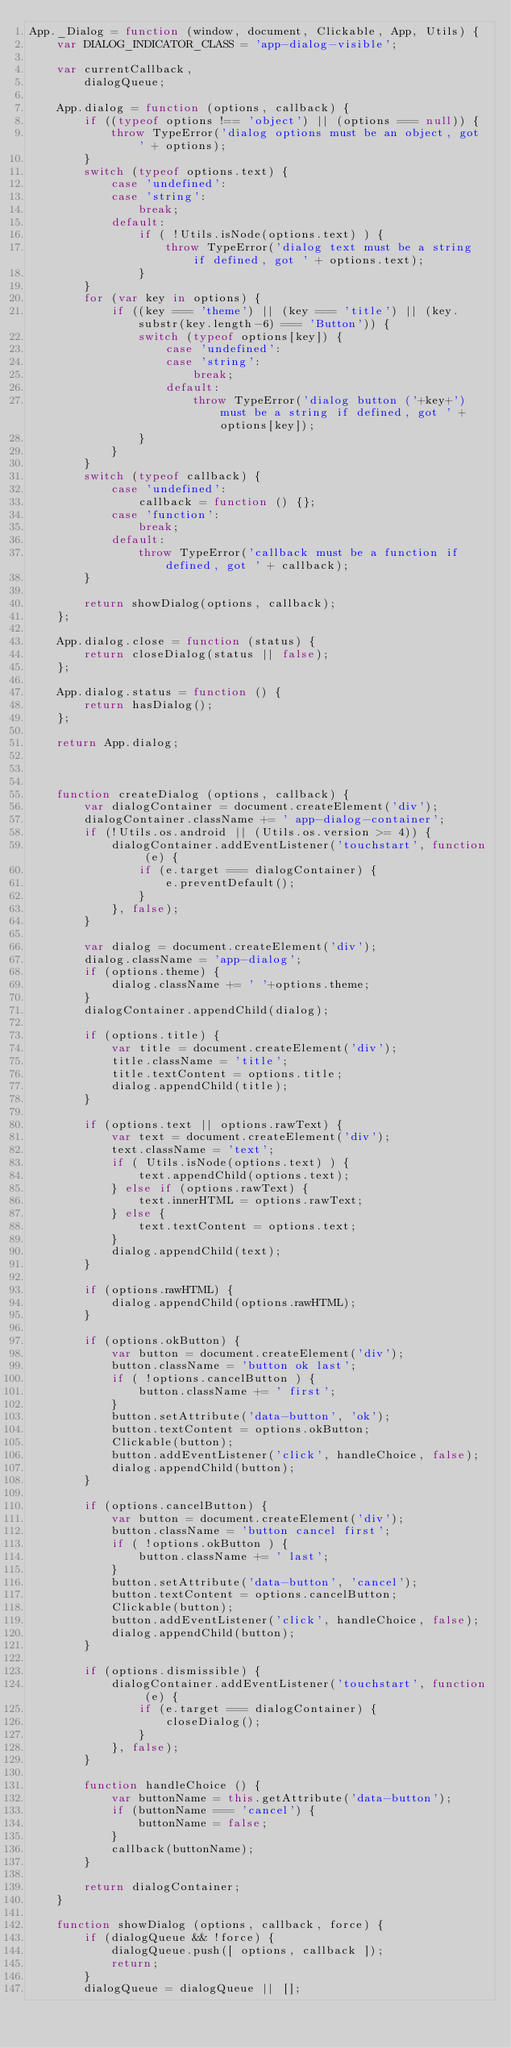Convert code to text. <code><loc_0><loc_0><loc_500><loc_500><_JavaScript_>App._Dialog = function (window, document, Clickable, App, Utils) {
	var DIALOG_INDICATOR_CLASS = 'app-dialog-visible';

	var currentCallback,
		dialogQueue;

	App.dialog = function (options, callback) {
		if ((typeof options !== 'object') || (options === null)) {
			throw TypeError('dialog options must be an object, got ' + options);
		}
		switch (typeof options.text) {
			case 'undefined':
			case 'string':
				break;
			default:
				if ( !Utils.isNode(options.text) ) {
					throw TypeError('dialog text must be a string if defined, got ' + options.text);
				}
		}
		for (var key in options) {
			if ((key === 'theme') || (key === 'title') || (key.substr(key.length-6) === 'Button')) {
				switch (typeof options[key]) {
					case 'undefined':
					case 'string':
						break;
					default:
						throw TypeError('dialog button ('+key+') must be a string if defined, got ' + options[key]);
				}
			}
		}
		switch (typeof callback) {
			case 'undefined':
				callback = function () {};
			case 'function':
				break;
			default:
				throw TypeError('callback must be a function if defined, got ' + callback);
		}

		return showDialog(options, callback);
	};

	App.dialog.close = function (status) {
		return closeDialog(status || false);
	};

	App.dialog.status = function () {
		return hasDialog();
	};

	return App.dialog;



	function createDialog (options, callback) {
		var dialogContainer = document.createElement('div');
		dialogContainer.className += ' app-dialog-container';
		if (!Utils.os.android || (Utils.os.version >= 4)) {
			dialogContainer.addEventListener('touchstart', function (e) {
				if (e.target === dialogContainer) {
					e.preventDefault();
				}
			}, false);
		}

		var dialog = document.createElement('div');
		dialog.className = 'app-dialog';
		if (options.theme) {
			dialog.className += ' '+options.theme;
		}
		dialogContainer.appendChild(dialog);

		if (options.title) {
			var title = document.createElement('div');
			title.className = 'title';
			title.textContent = options.title;
			dialog.appendChild(title);
		}

		if (options.text || options.rawText) {
			var text = document.createElement('div');
			text.className = 'text';
			if ( Utils.isNode(options.text) ) {
				text.appendChild(options.text);
			} else if (options.rawText) {
				text.innerHTML = options.rawText;
			} else {
				text.textContent = options.text;
			}
			dialog.appendChild(text);
		}

		if (options.rawHTML) {
			dialog.appendChild(options.rawHTML);
		}

		if (options.okButton) {
			var button = document.createElement('div');
			button.className = 'button ok last';
			if ( !options.cancelButton ) {
				button.className += ' first';
			}
			button.setAttribute('data-button', 'ok');
			button.textContent = options.okButton;
			Clickable(button);
			button.addEventListener('click', handleChoice, false);
			dialog.appendChild(button);
		}

		if (options.cancelButton) {
			var button = document.createElement('div');
			button.className = 'button cancel first';
			if ( !options.okButton ) {
				button.className += ' last';
			}
			button.setAttribute('data-button', 'cancel');
			button.textContent = options.cancelButton;
			Clickable(button);
			button.addEventListener('click', handleChoice, false);
			dialog.appendChild(button);
		}

		if (options.dismissible) {
			dialogContainer.addEventListener('touchstart', function (e) {
				if (e.target === dialogContainer) {
					closeDialog();
				}
			}, false);
		}

		function handleChoice () {
			var buttonName = this.getAttribute('data-button');
			if (buttonName === 'cancel') {
				buttonName = false;
			}
			callback(buttonName);
		}

		return dialogContainer;
	}

	function showDialog (options, callback, force) {
		if (dialogQueue && !force) {
			dialogQueue.push([ options, callback ]);
			return;
		}
		dialogQueue = dialogQueue || [];
</code> 